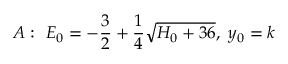Convert formula to latex. <formula><loc_0><loc_0><loc_500><loc_500>A \colon E _ { 0 } = - { \frac { 3 } { 2 } } + { \frac { 1 } { 4 } } \sqrt { H _ { 0 } + 3 6 } , y _ { 0 } = k</formula> 